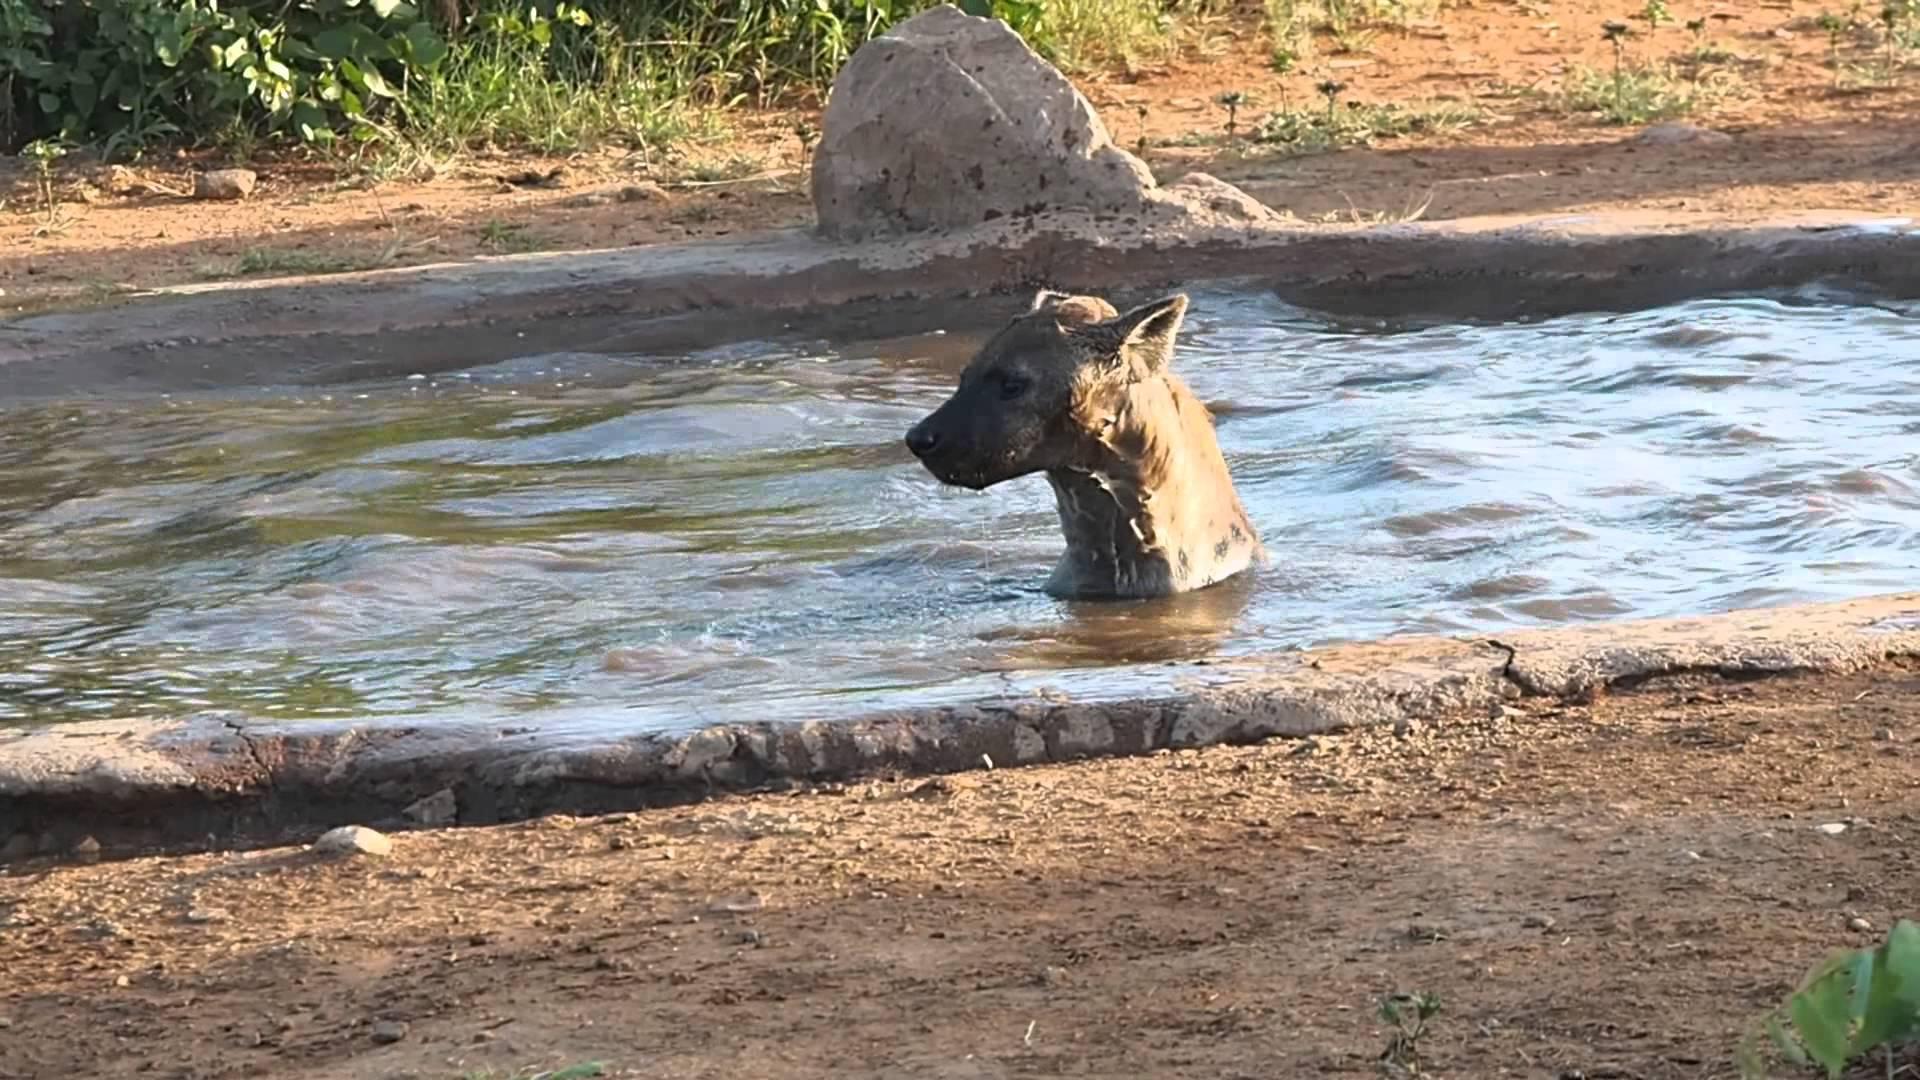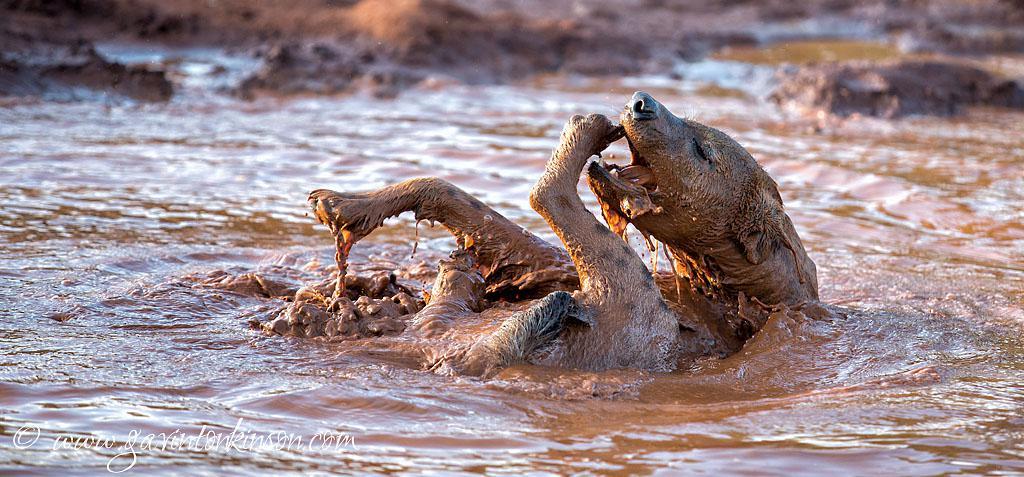The first image is the image on the left, the second image is the image on the right. For the images displayed, is the sentence "The left and right image contains the same number of hyenas in the water." factually correct? Answer yes or no. Yes. The first image is the image on the left, the second image is the image on the right. Examine the images to the left and right. Is the description "The right image shows one hyena on its back in water, with its head and at least its front paws sticking up in the air." accurate? Answer yes or no. Yes. 